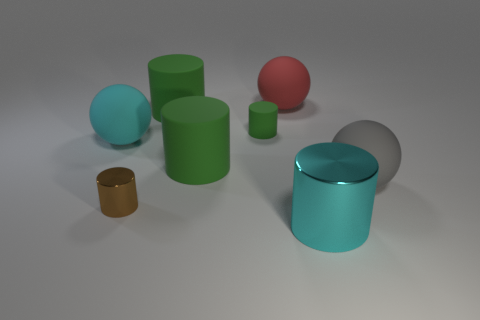Subtract all large cyan shiny cylinders. How many cylinders are left? 4 Add 1 large green objects. How many objects exist? 9 Subtract 2 cylinders. How many cylinders are left? 3 Subtract all brown cylinders. How many cylinders are left? 4 Subtract all balls. How many objects are left? 5 Subtract all cyan cylinders. Subtract all gray blocks. How many cylinders are left? 4 Subtract all yellow cubes. How many gray spheres are left? 1 Subtract all big rubber cylinders. Subtract all brown cylinders. How many objects are left? 5 Add 1 large cyan cylinders. How many large cyan cylinders are left? 2 Add 4 brown metal things. How many brown metal things exist? 5 